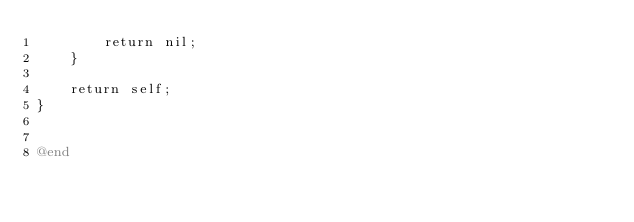<code> <loc_0><loc_0><loc_500><loc_500><_ObjectiveC_>        return nil;
    }

    return self;
}


@end
</code> 